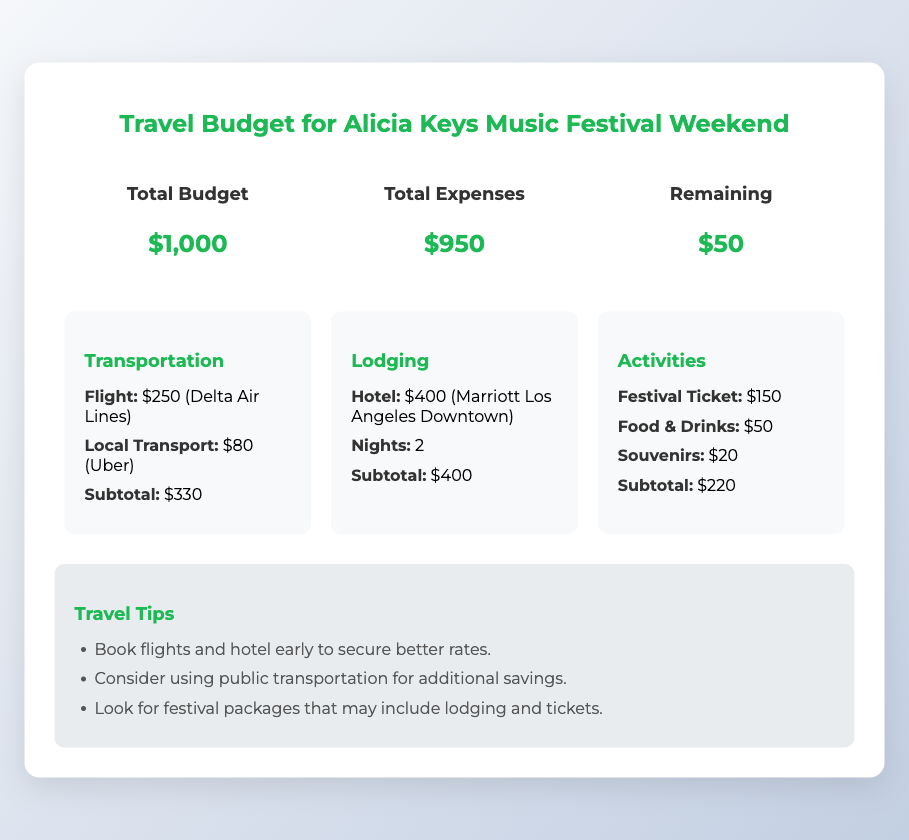What is the total budget? The total budget is clearly indicated in the document under the budget summary.
Answer: $1,000 What is the total expenses? The total expenses calculated from the individual categories are displayed in the budget summary.
Answer: $950 How much is the remaining budget? The remaining budget shown in the document is the difference between the total budget and total expenses.
Answer: $50 What is the subtotal for transportation? The subtotal for transportation can be found in the transportation expense category.
Answer: $330 What hotel is being used for lodging? The name of the hotel can be found in the lodging expense section.
Answer: Marriott Los Angeles Downtown How many nights is the lodging booked for? The number of nights stayed is specified in the lodging expense category.
Answer: 2 What is the cost of the festival ticket? The cost of the festival ticket can be found in the activities section of the document.
Answer: $150 What is one travel tip mentioned in the notes? A travel tip can be retrieved from the travel tips section in the notes.
Answer: Book flights and hotel early to secure better rates What category has the highest expense? The expense category with the highest amount can be identified from the expense breakdown.
Answer: Lodging 